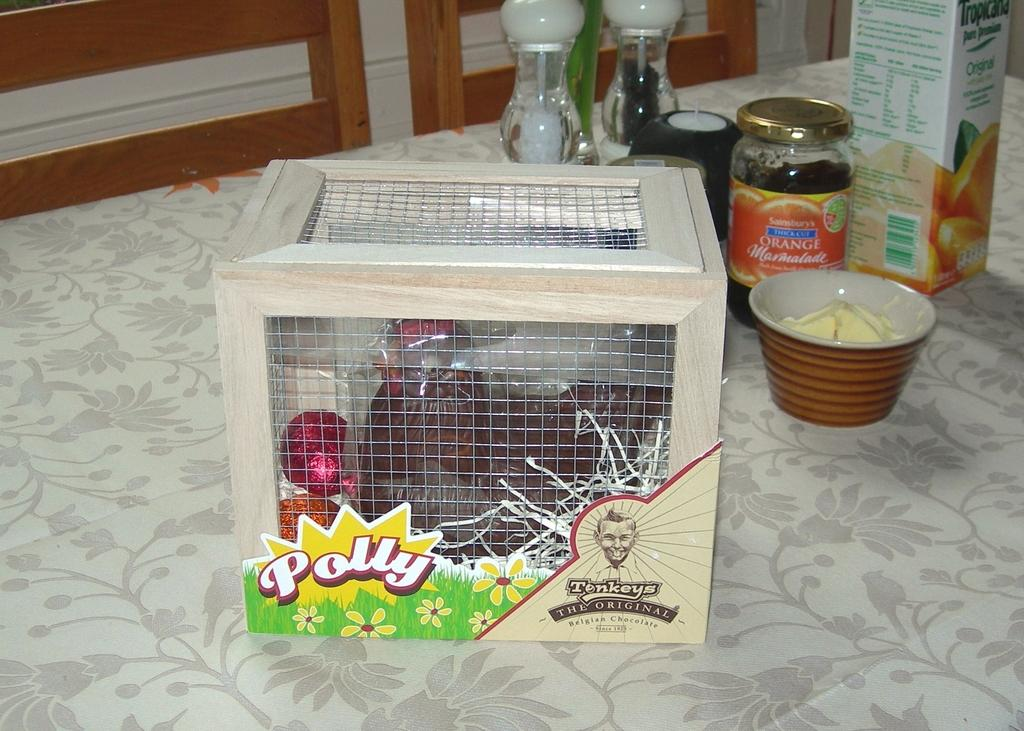Provide a one-sentence caption for the provided image. A doll named Polly is sitting in a crate on a counter. 